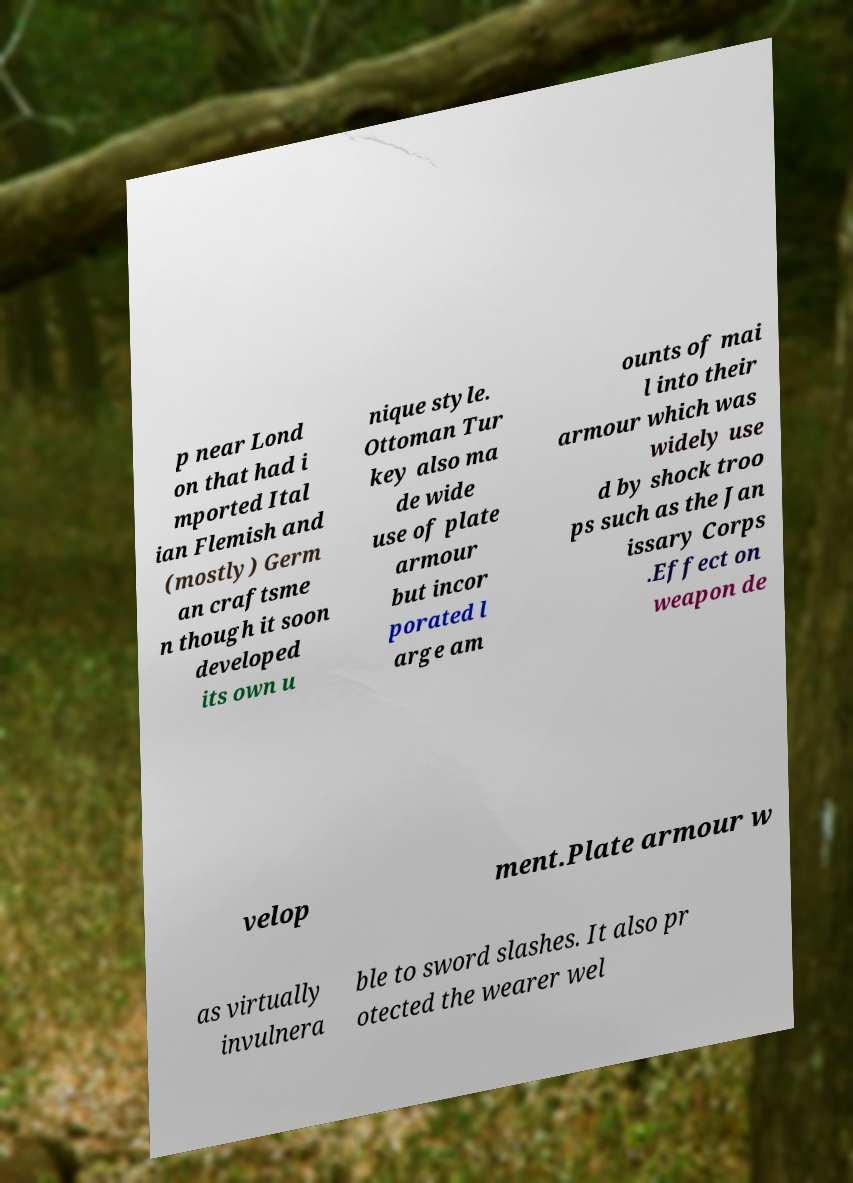Can you read and provide the text displayed in the image?This photo seems to have some interesting text. Can you extract and type it out for me? p near Lond on that had i mported Ital ian Flemish and (mostly) Germ an craftsme n though it soon developed its own u nique style. Ottoman Tur key also ma de wide use of plate armour but incor porated l arge am ounts of mai l into their armour which was widely use d by shock troo ps such as the Jan issary Corps .Effect on weapon de velop ment.Plate armour w as virtually invulnera ble to sword slashes. It also pr otected the wearer wel 